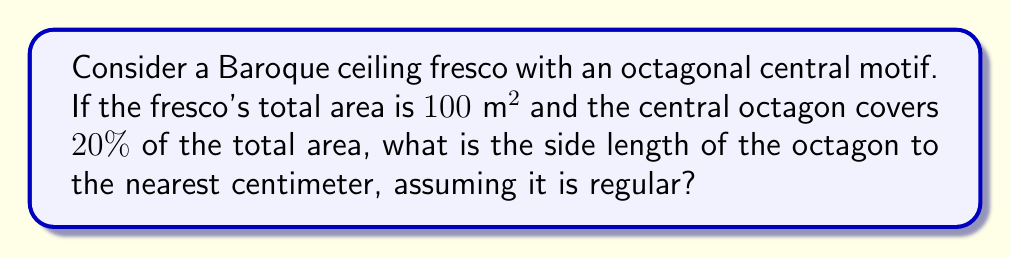Help me with this question. Let's approach this step-by-step:

1) First, we need to calculate the area of the octagonal motif:
   $20\%$ of $100\text{ m}^2 = 0.2 \times 100\text{ m}^2 = 20\text{ m}^2$

2) The area of a regular octagon with side length $s$ is given by the formula:
   $$A = 2(1+\sqrt{2})s^2$$

3) We can set up an equation:
   $$20 = 2(1+\sqrt{2})s^2$$

4) Solving for $s$:
   $$s^2 = \frac{20}{2(1+\sqrt{2})} = \frac{10}{1+\sqrt{2}}$$

   $$s = \sqrt{\frac{10}{1+\sqrt{2}}}$$

5) Using a calculator:
   $$s \approx 1.8477\text{ m}$$

6) Converting to centimeters:
   $$s \approx 184.77\text{ cm}$$

7) Rounding to the nearest centimeter:
   $$s \approx 185\text{ cm}$$

This solution combines geometric analysis typical in art history with mathematical precision, bridging our different perspectives on Baroque art.
Answer: 185 cm 